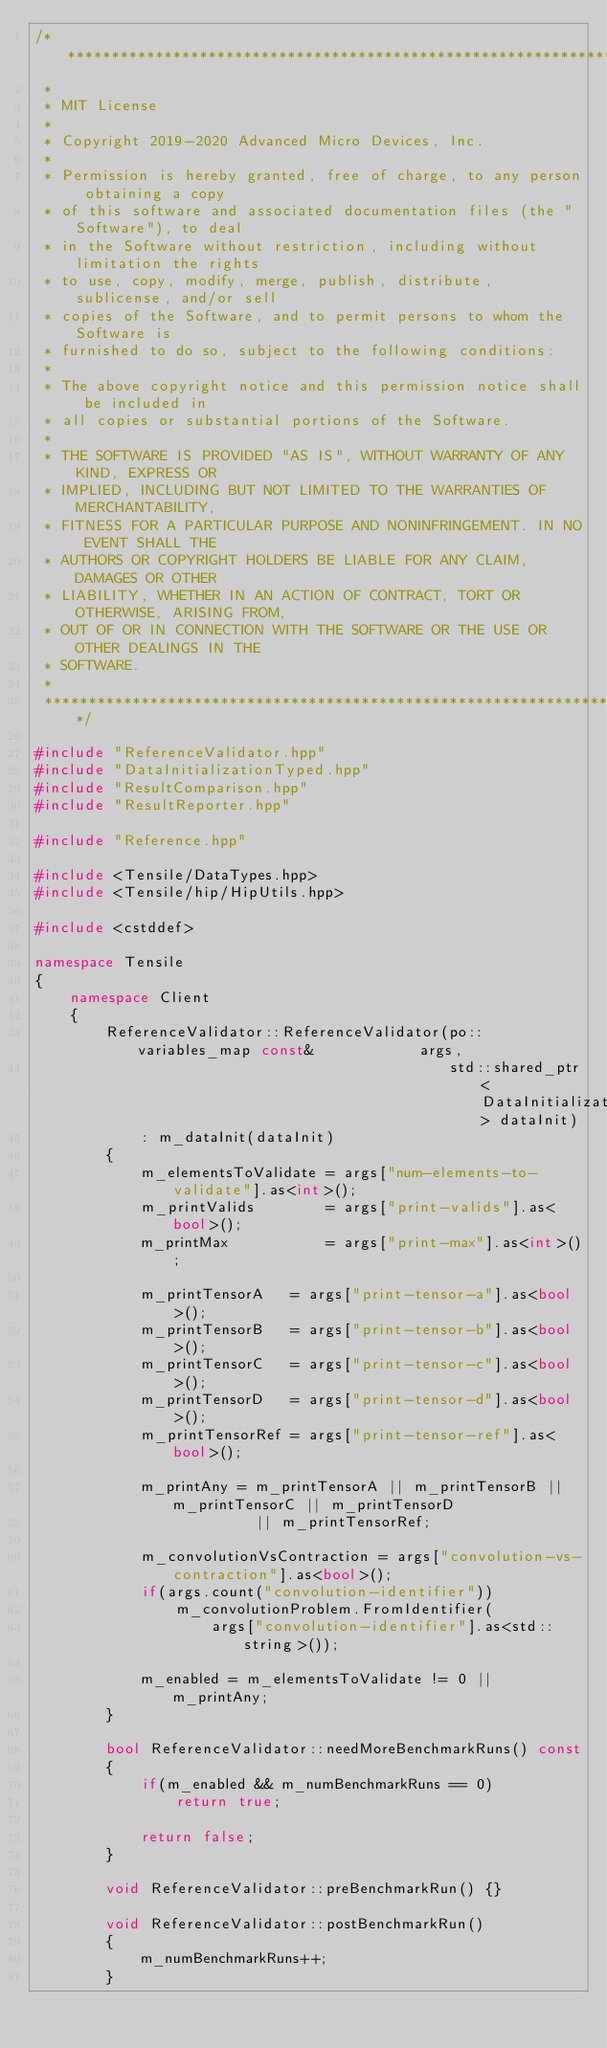Convert code to text. <code><loc_0><loc_0><loc_500><loc_500><_C++_>/*******************************************************************************
 *
 * MIT License
 *
 * Copyright 2019-2020 Advanced Micro Devices, Inc.
 *
 * Permission is hereby granted, free of charge, to any person obtaining a copy
 * of this software and associated documentation files (the "Software"), to deal
 * in the Software without restriction, including without limitation the rights
 * to use, copy, modify, merge, publish, distribute, sublicense, and/or sell
 * copies of the Software, and to permit persons to whom the Software is
 * furnished to do so, subject to the following conditions:
 *
 * The above copyright notice and this permission notice shall be included in
 * all copies or substantial portions of the Software.
 *
 * THE SOFTWARE IS PROVIDED "AS IS", WITHOUT WARRANTY OF ANY KIND, EXPRESS OR
 * IMPLIED, INCLUDING BUT NOT LIMITED TO THE WARRANTIES OF MERCHANTABILITY,
 * FITNESS FOR A PARTICULAR PURPOSE AND NONINFRINGEMENT. IN NO EVENT SHALL THE
 * AUTHORS OR COPYRIGHT HOLDERS BE LIABLE FOR ANY CLAIM, DAMAGES OR OTHER
 * LIABILITY, WHETHER IN AN ACTION OF CONTRACT, TORT OR OTHERWISE, ARISING FROM,
 * OUT OF OR IN CONNECTION WITH THE SOFTWARE OR THE USE OR OTHER DEALINGS IN THE
 * SOFTWARE.
 *
 *******************************************************************************/

#include "ReferenceValidator.hpp"
#include "DataInitializationTyped.hpp"
#include "ResultComparison.hpp"
#include "ResultReporter.hpp"

#include "Reference.hpp"

#include <Tensile/DataTypes.hpp>
#include <Tensile/hip/HipUtils.hpp>

#include <cstddef>

namespace Tensile
{
    namespace Client
    {
        ReferenceValidator::ReferenceValidator(po::variables_map const&            args,
                                               std::shared_ptr<DataInitialization> dataInit)
            : m_dataInit(dataInit)
        {
            m_elementsToValidate = args["num-elements-to-validate"].as<int>();
            m_printValids        = args["print-valids"].as<bool>();
            m_printMax           = args["print-max"].as<int>();

            m_printTensorA   = args["print-tensor-a"].as<bool>();
            m_printTensorB   = args["print-tensor-b"].as<bool>();
            m_printTensorC   = args["print-tensor-c"].as<bool>();
            m_printTensorD   = args["print-tensor-d"].as<bool>();
            m_printTensorRef = args["print-tensor-ref"].as<bool>();

            m_printAny = m_printTensorA || m_printTensorB || m_printTensorC || m_printTensorD
                         || m_printTensorRef;

            m_convolutionVsContraction = args["convolution-vs-contraction"].as<bool>();
            if(args.count("convolution-identifier"))
                m_convolutionProblem.FromIdentifier(
                    args["convolution-identifier"].as<std::string>());

            m_enabled = m_elementsToValidate != 0 || m_printAny;
        }

        bool ReferenceValidator::needMoreBenchmarkRuns() const
        {
            if(m_enabled && m_numBenchmarkRuns == 0)
                return true;

            return false;
        }

        void ReferenceValidator::preBenchmarkRun() {}

        void ReferenceValidator::postBenchmarkRun()
        {
            m_numBenchmarkRuns++;
        }
</code> 